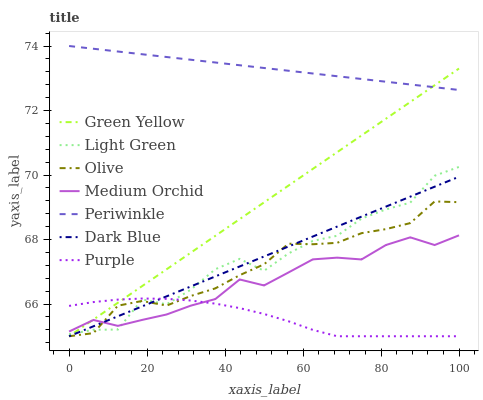Does Medium Orchid have the minimum area under the curve?
Answer yes or no. No. Does Medium Orchid have the maximum area under the curve?
Answer yes or no. No. Is Medium Orchid the smoothest?
Answer yes or no. No. Is Medium Orchid the roughest?
Answer yes or no. No. Does Medium Orchid have the lowest value?
Answer yes or no. No. Does Medium Orchid have the highest value?
Answer yes or no. No. Is Dark Blue less than Periwinkle?
Answer yes or no. Yes. Is Periwinkle greater than Purple?
Answer yes or no. Yes. Does Dark Blue intersect Periwinkle?
Answer yes or no. No. 